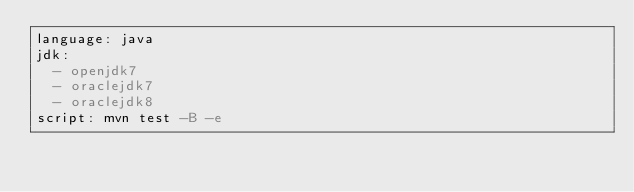Convert code to text. <code><loc_0><loc_0><loc_500><loc_500><_YAML_>language: java
jdk:
  - openjdk7
  - oraclejdk7
  - oraclejdk8
script: mvn test -B -e
</code> 